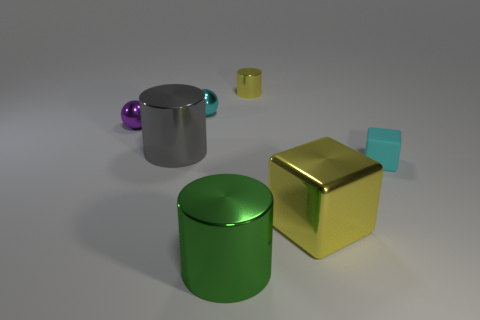Does the purple ball have the same size as the gray object that is right of the purple thing?
Offer a terse response. No. What number of metallic things are large green cylinders or small yellow blocks?
Ensure brevity in your answer.  1. How many other things have the same shape as the small purple object?
Give a very brief answer. 1. Do the yellow metallic thing that is in front of the small matte object and the cylinder that is in front of the shiny cube have the same size?
Give a very brief answer. Yes. There is a tiny matte thing right of the gray cylinder; what shape is it?
Your response must be concise. Cube. There is another object that is the same shape as the large yellow metallic object; what is it made of?
Your answer should be very brief. Rubber. Does the yellow object behind the matte object have the same size as the tiny purple sphere?
Offer a very short reply. Yes. There is a purple ball; how many purple objects are on the left side of it?
Keep it short and to the point. 0. Is the number of yellow cubes that are in front of the big green shiny cylinder less than the number of shiny objects that are to the right of the tiny cyan sphere?
Give a very brief answer. Yes. How many large metal cylinders are there?
Give a very brief answer. 2. 